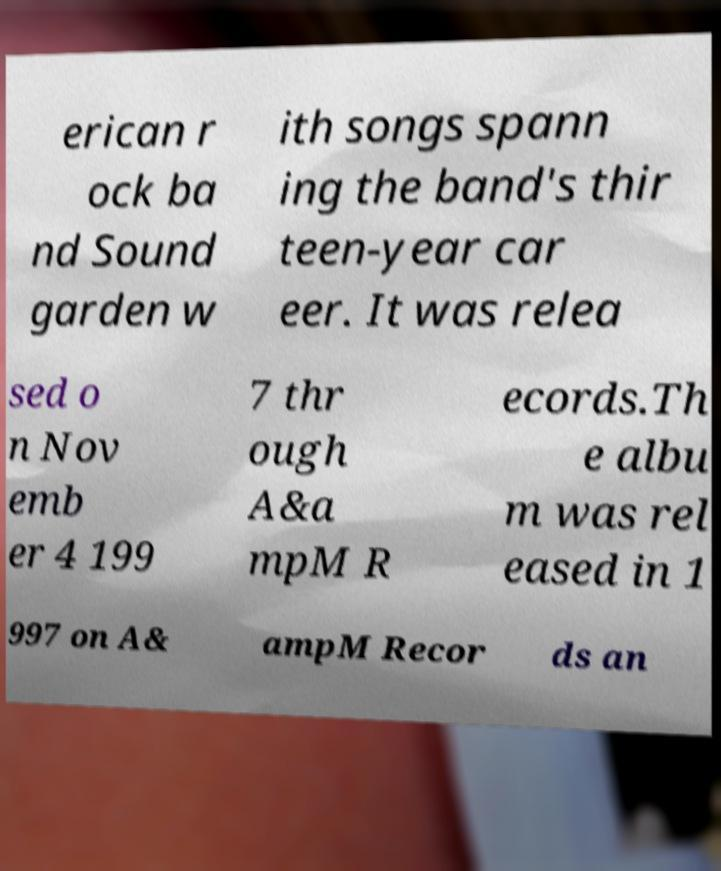Could you extract and type out the text from this image? erican r ock ba nd Sound garden w ith songs spann ing the band's thir teen-year car eer. It was relea sed o n Nov emb er 4 199 7 thr ough A&a mpM R ecords.Th e albu m was rel eased in 1 997 on A& ampM Recor ds an 